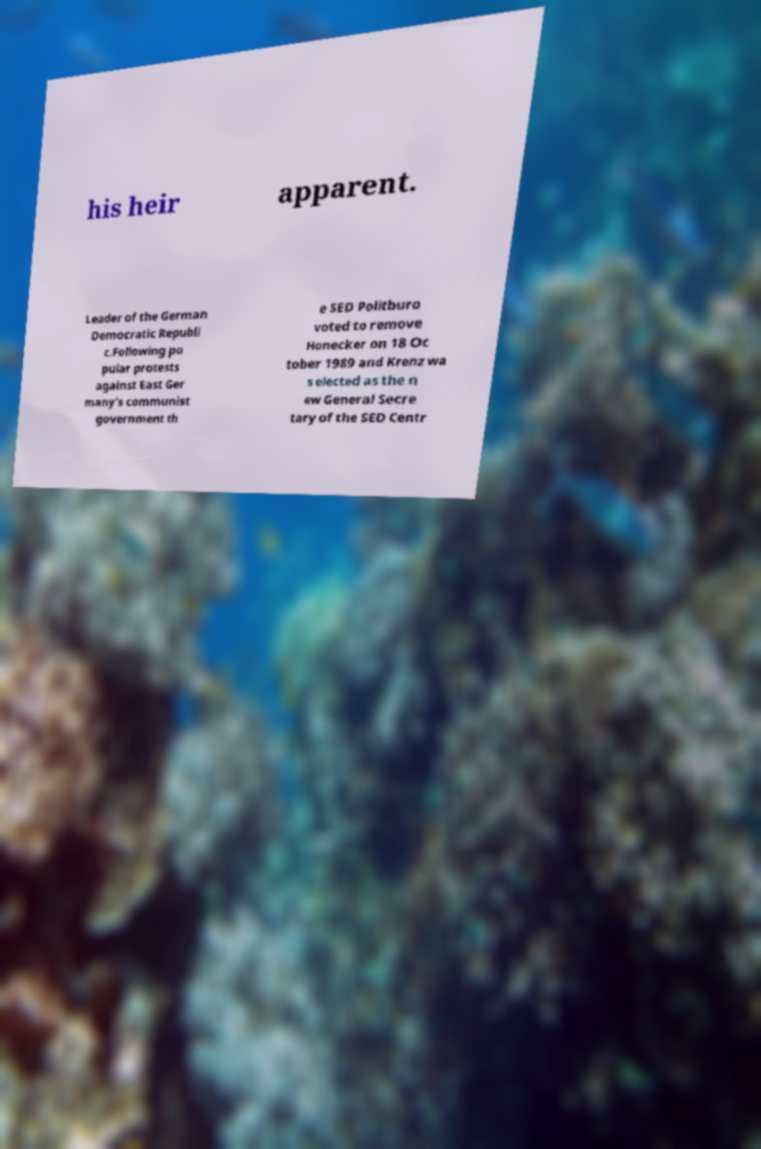Could you assist in decoding the text presented in this image and type it out clearly? his heir apparent. Leader of the German Democratic Republi c.Following po pular protests against East Ger many's communist government th e SED Politburo voted to remove Honecker on 18 Oc tober 1989 and Krenz wa s elected as the n ew General Secre tary of the SED Centr 